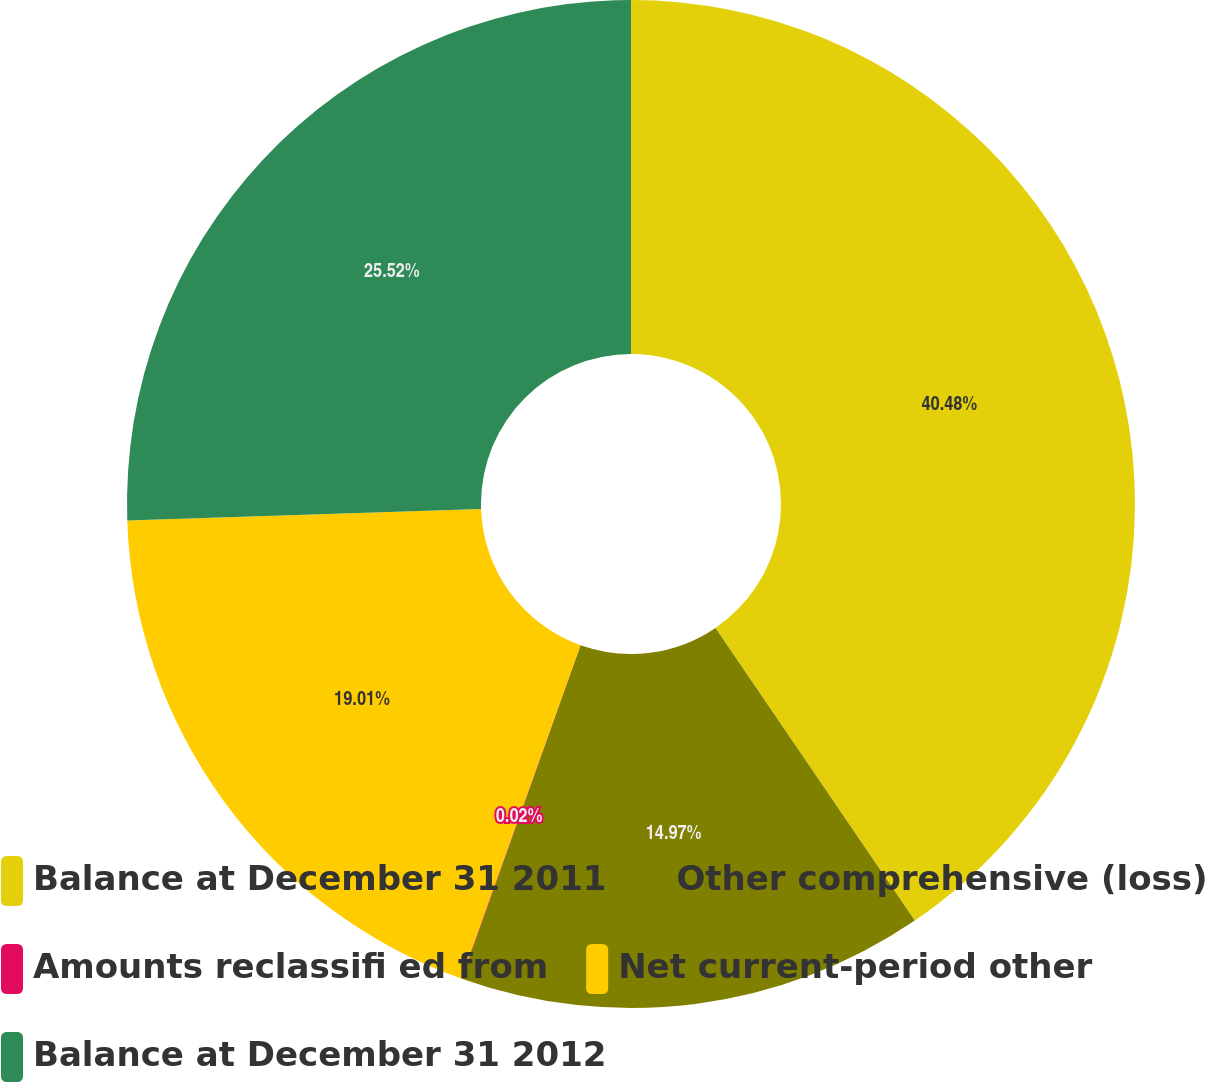Convert chart. <chart><loc_0><loc_0><loc_500><loc_500><pie_chart><fcel>Balance at December 31 2011<fcel>Other comprehensive (loss)<fcel>Amounts reclassifi ed from<fcel>Net current-period other<fcel>Balance at December 31 2012<nl><fcel>40.48%<fcel>14.97%<fcel>0.02%<fcel>19.01%<fcel>25.52%<nl></chart> 